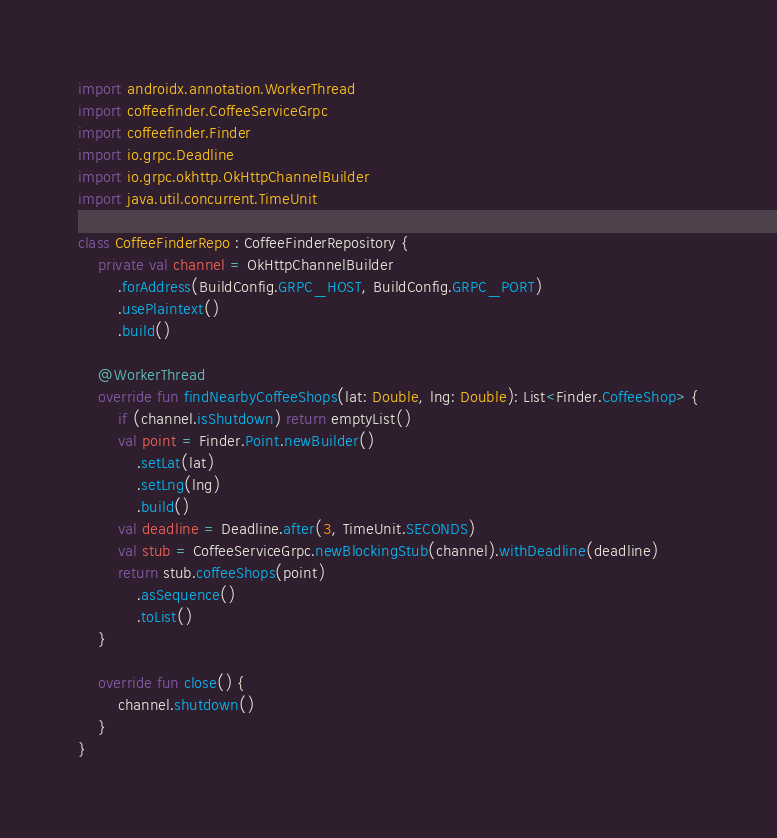<code> <loc_0><loc_0><loc_500><loc_500><_Kotlin_>import androidx.annotation.WorkerThread
import coffeefinder.CoffeeServiceGrpc
import coffeefinder.Finder
import io.grpc.Deadline
import io.grpc.okhttp.OkHttpChannelBuilder
import java.util.concurrent.TimeUnit

class CoffeeFinderRepo : CoffeeFinderRepository {
    private val channel = OkHttpChannelBuilder
        .forAddress(BuildConfig.GRPC_HOST, BuildConfig.GRPC_PORT)
        .usePlaintext()
        .build()

    @WorkerThread
    override fun findNearbyCoffeeShops(lat: Double, lng: Double): List<Finder.CoffeeShop> {
        if (channel.isShutdown) return emptyList()
        val point = Finder.Point.newBuilder()
            .setLat(lat)
            .setLng(lng)
            .build()
        val deadline = Deadline.after(3, TimeUnit.SECONDS)
        val stub = CoffeeServiceGrpc.newBlockingStub(channel).withDeadline(deadline)
        return stub.coffeeShops(point)
            .asSequence()
            .toList()
    }

    override fun close() {
        channel.shutdown()
    }
}
</code> 